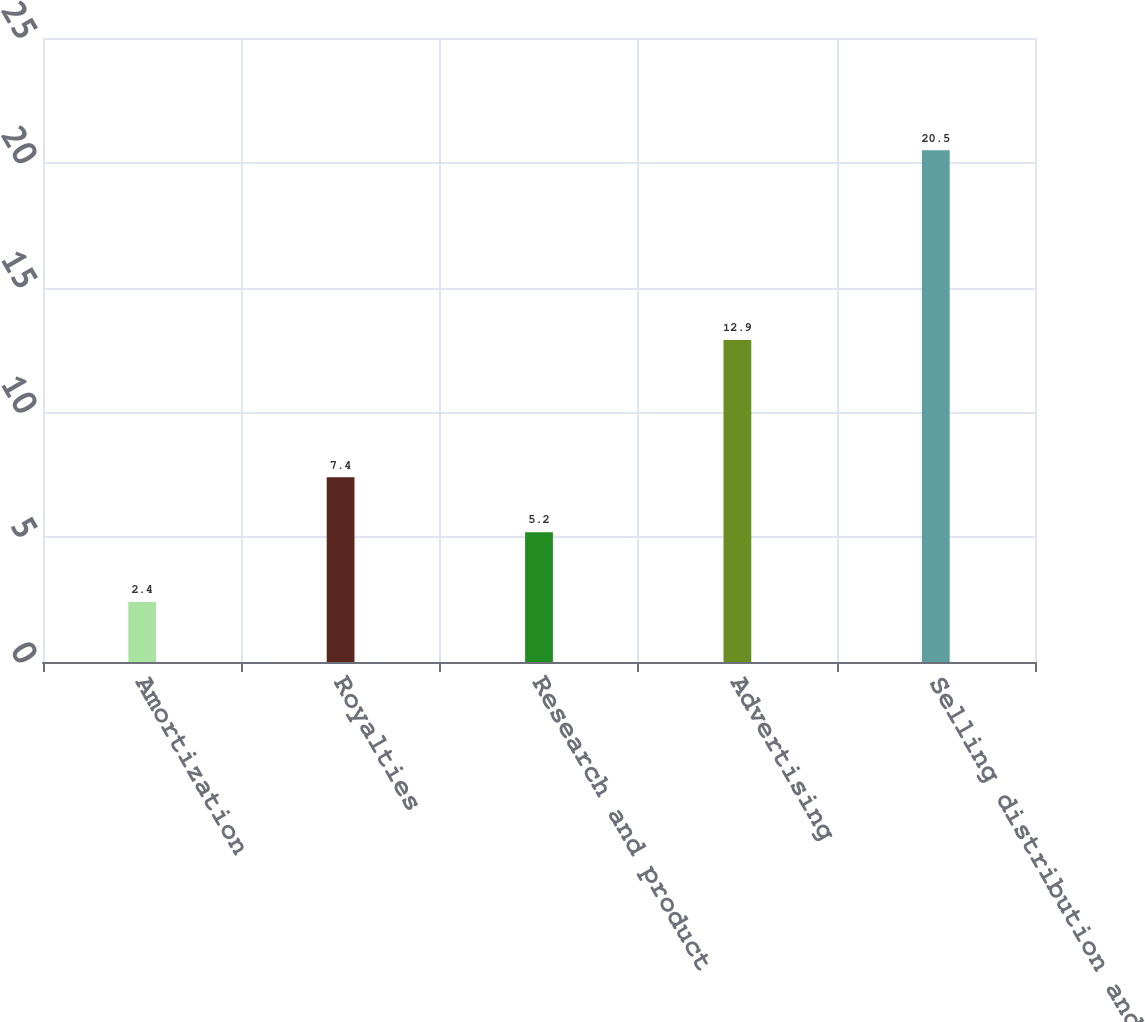<chart> <loc_0><loc_0><loc_500><loc_500><bar_chart><fcel>Amortization<fcel>Royalties<fcel>Research and product<fcel>Advertising<fcel>Selling distribution and<nl><fcel>2.4<fcel>7.4<fcel>5.2<fcel>12.9<fcel>20.5<nl></chart> 